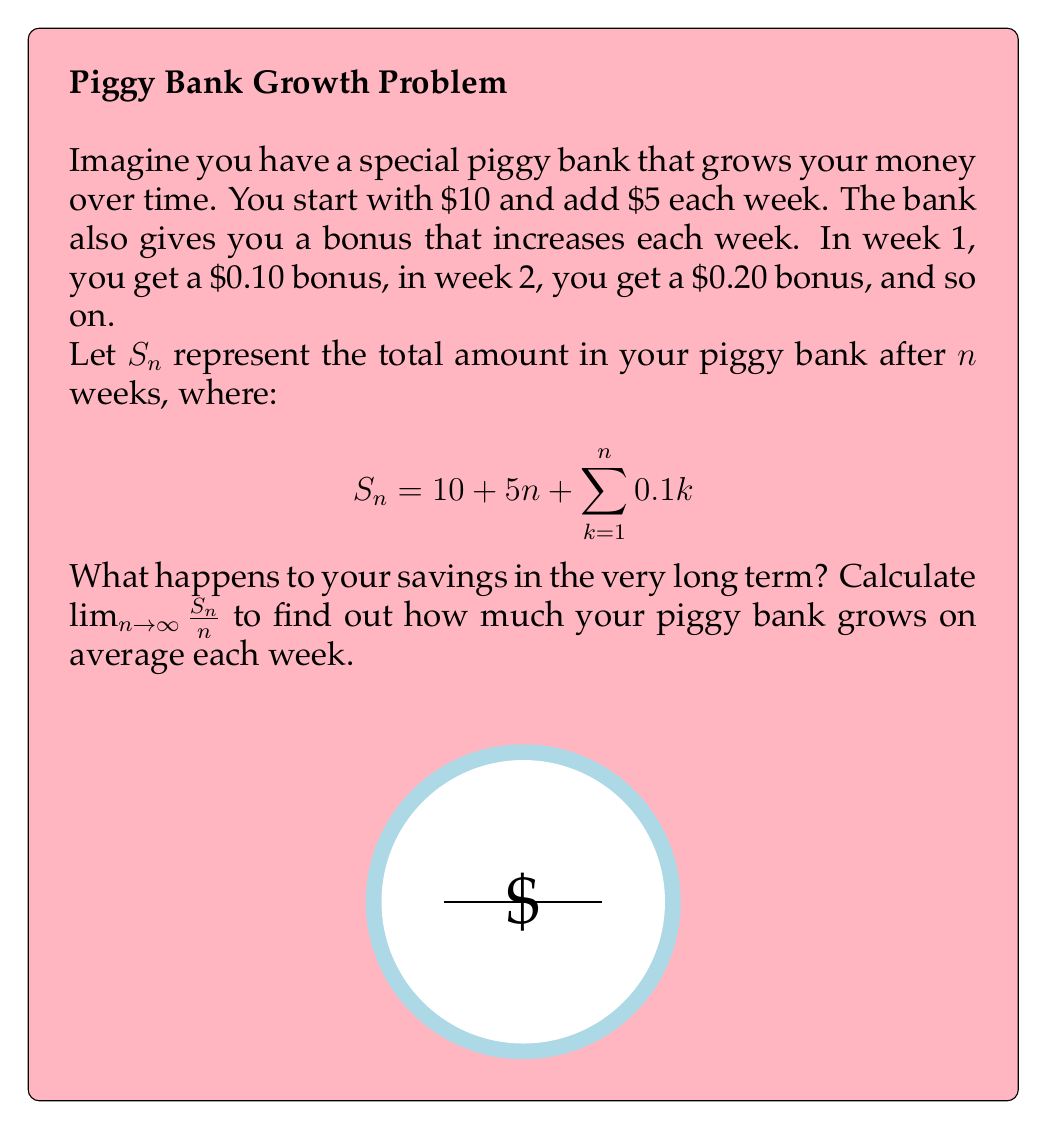Can you answer this question? Let's approach this step-by-step:

1) First, let's simplify the sum in the equation:
   $$\sum_{k=1}^n 0.1k = 0.1 \cdot \frac{n(n+1)}{2}$$
   This is because the sum of the first n integers is $\frac{n(n+1)}{2}$.

2) Now, we can rewrite $S_n$ as:
   $$S_n = 10 + 5n + 0.1 \cdot \frac{n(n+1)}{2}$$

3) Let's expand this:
   $$S_n = 10 + 5n + 0.05n^2 + 0.05n$$

4) Simplify:
   $$S_n = 10 + 5.05n + 0.05n^2$$

5) Now, we need to calculate $\lim_{n \to \infty} \frac{S_n}{n}$:
   $$\lim_{n \to \infty} \frac{S_n}{n} = \lim_{n \to \infty} \frac{10 + 5.05n + 0.05n^2}{n}$$

6) Divide both numerator and denominator by the highest power of n (which is $n$):
   $$\lim_{n \to \infty} \frac{S_n}{n} = \lim_{n \to \infty} (\frac{10}{n} + 5.05 + 0.05n)$$

7) As $n$ approaches infinity:
   - $\frac{10}{n}$ approaches 0
   - 5.05 remains constant
   - 0.05n grows infinitely large

8) Therefore:
   $$\lim_{n \to \infty} \frac{S_n}{n} = \infty$$

This means that in the long term, your piggy bank grows without bound, increasing faster than a linear rate.
Answer: $\infty$ 